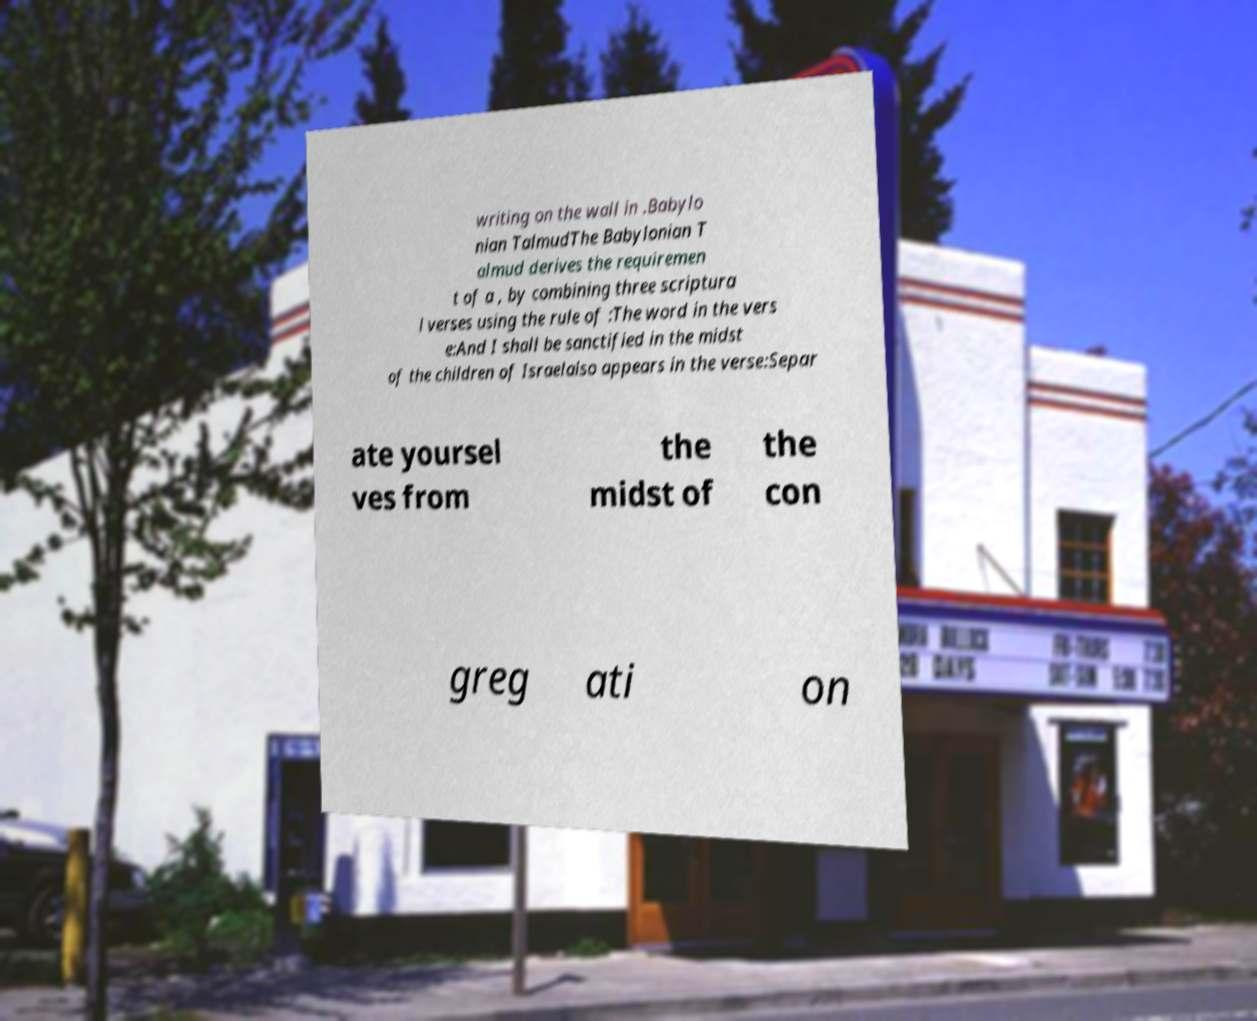Can you read and provide the text displayed in the image?This photo seems to have some interesting text. Can you extract and type it out for me? writing on the wall in .Babylo nian TalmudThe Babylonian T almud derives the requiremen t of a , by combining three scriptura l verses using the rule of :The word in the vers e:And I shall be sanctified in the midst of the children of Israelalso appears in the verse:Separ ate yoursel ves from the midst of the con greg ati on 